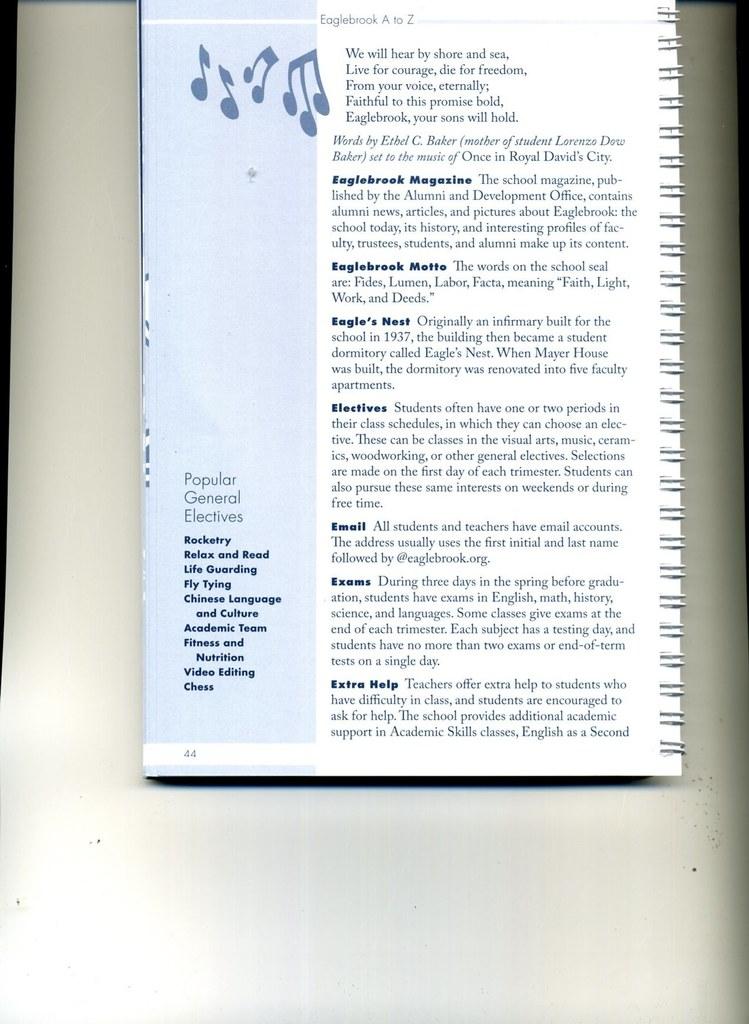What page is this?
Provide a succinct answer. 44. What is subheading 4?
Your response must be concise. Electives. 